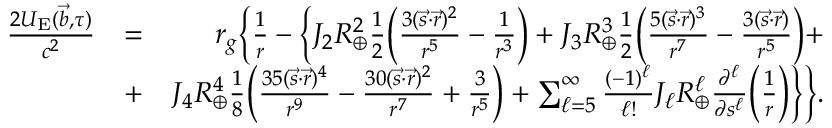Convert formula to latex. <formula><loc_0><loc_0><loc_500><loc_500>\begin{array} { r l r } { \frac { 2 U _ { E } ( { \vec { b } } , \tau ) } { c ^ { 2 } } } & { = } & { r _ { g } \left \{ \frac { 1 } { r } - \left \{ J _ { 2 } R _ { \oplus } ^ { 2 } \frac { 1 } { 2 } \left ( \frac { 3 ( { \vec { s } } \cdot { \vec { r } } ) ^ { 2 } } { r ^ { 5 } } - \frac { 1 } { r ^ { 3 } } \right ) + J _ { 3 } R _ { \oplus } ^ { 3 } \frac { 1 } { 2 } \left ( \frac { 5 ( { \vec { s } } \cdot { \vec { r } } ) ^ { 3 } } { r ^ { 7 } } - \frac { 3 ( { \vec { s } } \cdot { \vec { r } } ) } { r ^ { 5 } } \right ) + } \\ & { + } & { J _ { 4 } R _ { \oplus } ^ { 4 } \frac { 1 } { 8 } \left ( \frac { 3 5 ( { \vec { s } } \cdot { \vec { r } } ) ^ { 4 } } { r ^ { 9 } } - \frac { 3 0 ( { \vec { s } } \cdot { \vec { r } } ) ^ { 2 } } { r ^ { 7 } } + \frac { 3 } { r ^ { 5 } } \right ) + \sum _ { \ell = 5 } ^ { \infty } \frac { ( - 1 ) ^ { \ell } } { \ell ! } J _ { \ell } R _ { \oplus } ^ { \ell } \frac { \partial ^ { \ell } } { \partial s ^ { \ell } } \left ( \frac { 1 } { r } \right ) \right \} \right \} . } \end{array}</formula> 